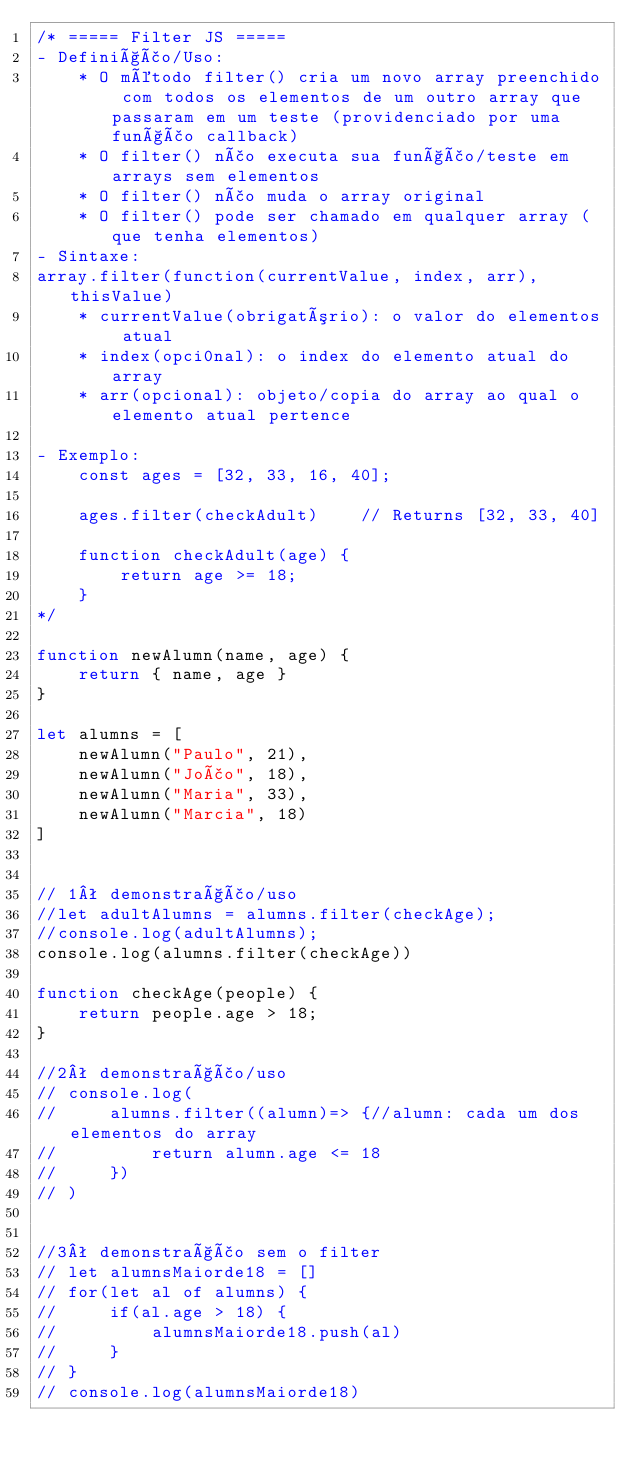Convert code to text. <code><loc_0><loc_0><loc_500><loc_500><_JavaScript_>/* ===== Filter JS =====
- Definição/Uso:
    * O método filter() cria um novo array preenchido com todos os elementos de um outro array que passaram em um teste (providenciado por uma função callback)
    * O filter() não executa sua função/teste em arrays sem elementos
    * O filter() não muda o array original
    * O filter() pode ser chamado em qualquer array (que tenha elementos)
- Sintaxe:
array.filter(function(currentValue, index, arr), thisValue)
    * currentValue(obrigatório): o valor do elementos atual
    * index(opci0nal): o index do elemento atual do array
    * arr(opcional): objeto/copia do array ao qual o elemento atual pertence

- Exemplo:
    const ages = [32, 33, 16, 40];

    ages.filter(checkAdult)    // Returns [32, 33, 40]

    function checkAdult(age) {
        return age >= 18;
    }
*/

function newAlumn(name, age) {
    return { name, age }
}

let alumns = [
    newAlumn("Paulo", 21),
    newAlumn("João", 18),
    newAlumn("Maria", 33),
    newAlumn("Marcia", 18)
]


// 1ª demonstração/uso
//let adultAlumns = alumns.filter(checkAge);
//console.log(adultAlumns);
console.log(alumns.filter(checkAge))

function checkAge(people) {
    return people.age > 18;
}

//2ª demonstração/uso
// console.log(
//     alumns.filter((alumn)=> {//alumn: cada um dos elementos do array
//         return alumn.age <= 18
//     })
// )


//3ª demonstração sem o filter
// let alumnsMaiorde18 = []
// for(let al of alumns) {
//     if(al.age > 18) {
//         alumnsMaiorde18.push(al)
//     }
// }
// console.log(alumnsMaiorde18)
</code> 